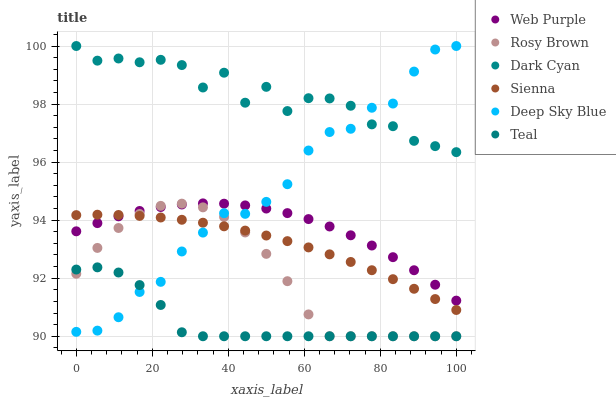Does Teal have the minimum area under the curve?
Answer yes or no. Yes. Does Dark Cyan have the maximum area under the curve?
Answer yes or no. Yes. Does Rosy Brown have the minimum area under the curve?
Answer yes or no. No. Does Rosy Brown have the maximum area under the curve?
Answer yes or no. No. Is Sienna the smoothest?
Answer yes or no. Yes. Is Dark Cyan the roughest?
Answer yes or no. Yes. Is Rosy Brown the smoothest?
Answer yes or no. No. Is Rosy Brown the roughest?
Answer yes or no. No. Does Rosy Brown have the lowest value?
Answer yes or no. Yes. Does Sienna have the lowest value?
Answer yes or no. No. Does Dark Cyan have the highest value?
Answer yes or no. Yes. Does Rosy Brown have the highest value?
Answer yes or no. No. Is Web Purple less than Dark Cyan?
Answer yes or no. Yes. Is Dark Cyan greater than Sienna?
Answer yes or no. Yes. Does Rosy Brown intersect Teal?
Answer yes or no. Yes. Is Rosy Brown less than Teal?
Answer yes or no. No. Is Rosy Brown greater than Teal?
Answer yes or no. No. Does Web Purple intersect Dark Cyan?
Answer yes or no. No. 